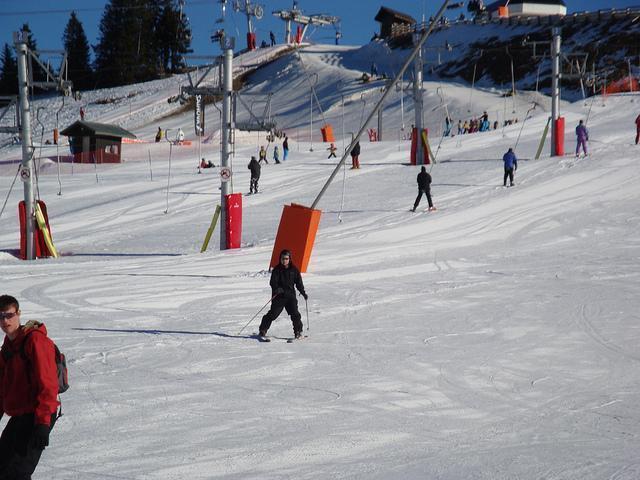What is the man dressed in all black and in the middle of the scene holding?
Choose the right answer from the provided options to respond to the question.
Options: Carrot, rabbit, ski poles, baby. Ski poles. 